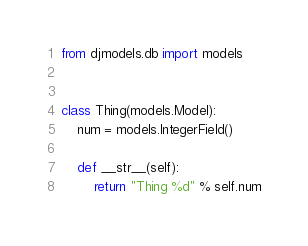Convert code to text. <code><loc_0><loc_0><loc_500><loc_500><_Python_>from djmodels.db import models


class Thing(models.Model):
    num = models.IntegerField()

    def __str__(self):
        return "Thing %d" % self.num
</code> 